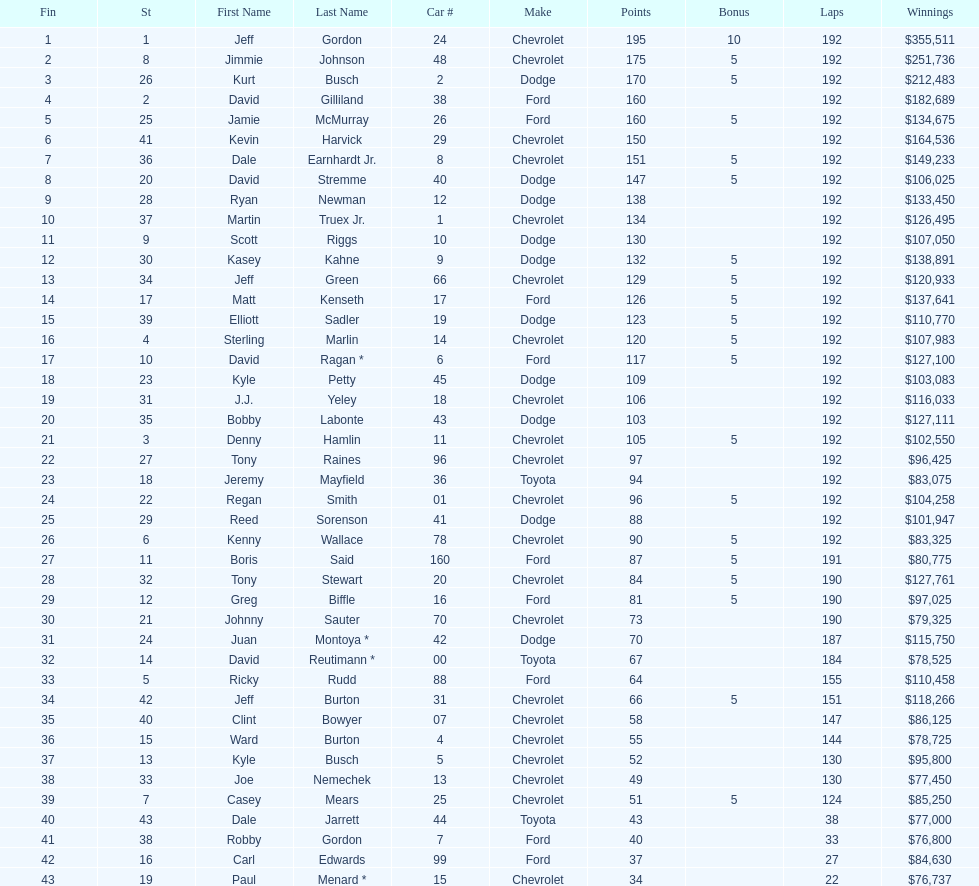What driver earned the least amount of winnings? Paul Menard *. 